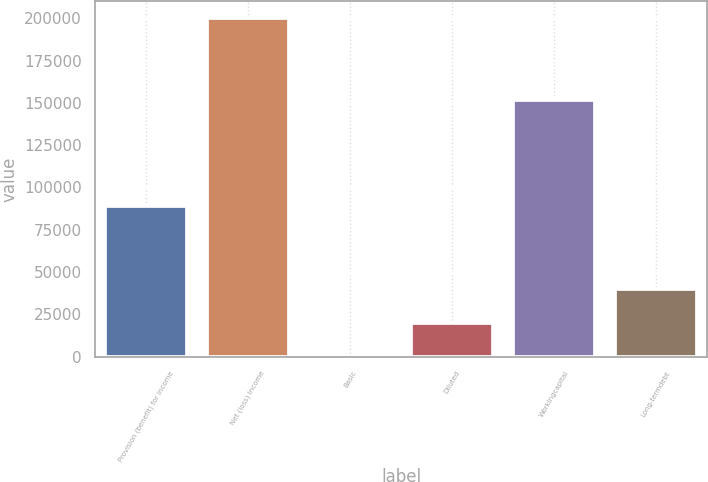<chart> <loc_0><loc_0><loc_500><loc_500><bar_chart><fcel>Provision (benefit) for income<fcel>Net (loss) income<fcel>Basic<fcel>Diluted<fcel>Workingcapital<fcel>Long-termdebt<nl><fcel>88947<fcel>199993<fcel>1.5<fcel>20000.7<fcel>151946<fcel>39999.8<nl></chart> 